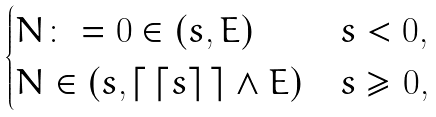<formula> <loc_0><loc_0><loc_500><loc_500>\begin{cases} N \colon = 0 \in ( s , E ) & s < 0 , \\ N \in ( s , \lceil \, \lceil s \rceil \, \rceil \wedge E ) & s \geq 0 , \end{cases}</formula> 